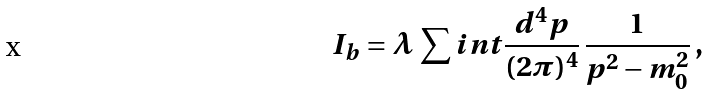Convert formula to latex. <formula><loc_0><loc_0><loc_500><loc_500>I _ { b } = \lambda \, \sum i n t \frac { d ^ { 4 } p } { ( 2 \pi ) ^ { 4 } } \, \frac { 1 } { p ^ { 2 } - m _ { 0 } ^ { 2 } } \, ,</formula> 